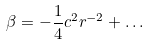<formula> <loc_0><loc_0><loc_500><loc_500>\beta = - \frac { 1 } { 4 } c ^ { 2 } r ^ { - 2 } + \dots</formula> 